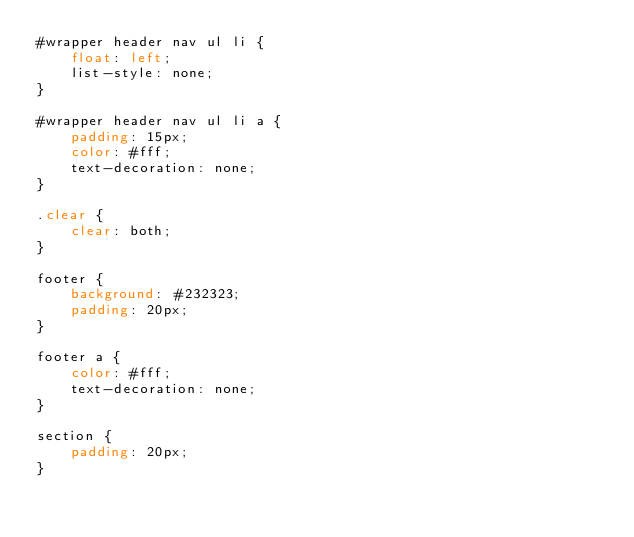Convert code to text. <code><loc_0><loc_0><loc_500><loc_500><_CSS_>#wrapper header nav ul li {
    float: left;
    list-style: none;
}

#wrapper header nav ul li a {
    padding: 15px;
    color: #fff;
    text-decoration: none;
}

.clear {
    clear: both;
}

footer {
    background: #232323;
    padding: 20px;
}

footer a {
    color: #fff;
    text-decoration: none;
}

section {
    padding: 20px;
}</code> 